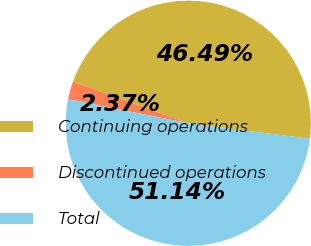Convert chart. <chart><loc_0><loc_0><loc_500><loc_500><pie_chart><fcel>Continuing operations<fcel>Discontinued operations<fcel>Total<nl><fcel>46.49%<fcel>2.37%<fcel>51.14%<nl></chart> 